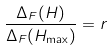Convert formula to latex. <formula><loc_0><loc_0><loc_500><loc_500>\frac { \Delta _ { F } ( H ) } { \Delta _ { F } ( H _ { \max } ) } = r</formula> 